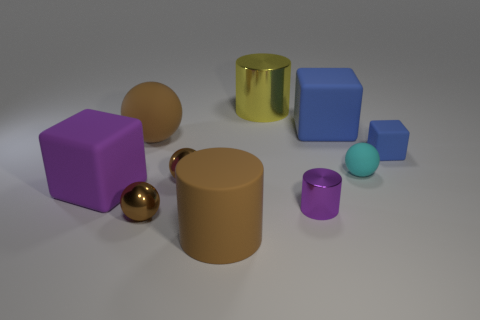How many objects are tiny cyan spheres or large matte objects that are in front of the small blue matte block?
Your answer should be very brief. 3. How many other things are the same material as the cyan thing?
Give a very brief answer. 5. What number of objects are either small purple objects or big brown matte cylinders?
Offer a terse response. 2. Are there more large blue matte things that are to the right of the big blue matte thing than purple metallic objects behind the purple rubber block?
Your response must be concise. No. Do the matte ball that is on the left side of the tiny purple cylinder and the matte ball on the right side of the yellow shiny cylinder have the same color?
Give a very brief answer. No. How big is the brown rubber thing behind the large brown thing in front of the brown matte thing that is behind the small cyan thing?
Your response must be concise. Large. There is another big rubber thing that is the same shape as the large purple rubber object; what is its color?
Provide a succinct answer. Blue. Is the number of cyan rubber objects in front of the cyan sphere greater than the number of big brown objects?
Make the answer very short. No. There is a small purple thing; is its shape the same as the large brown rubber thing behind the brown rubber cylinder?
Keep it short and to the point. No. Is there anything else that has the same size as the yellow metallic cylinder?
Your answer should be compact. Yes. 